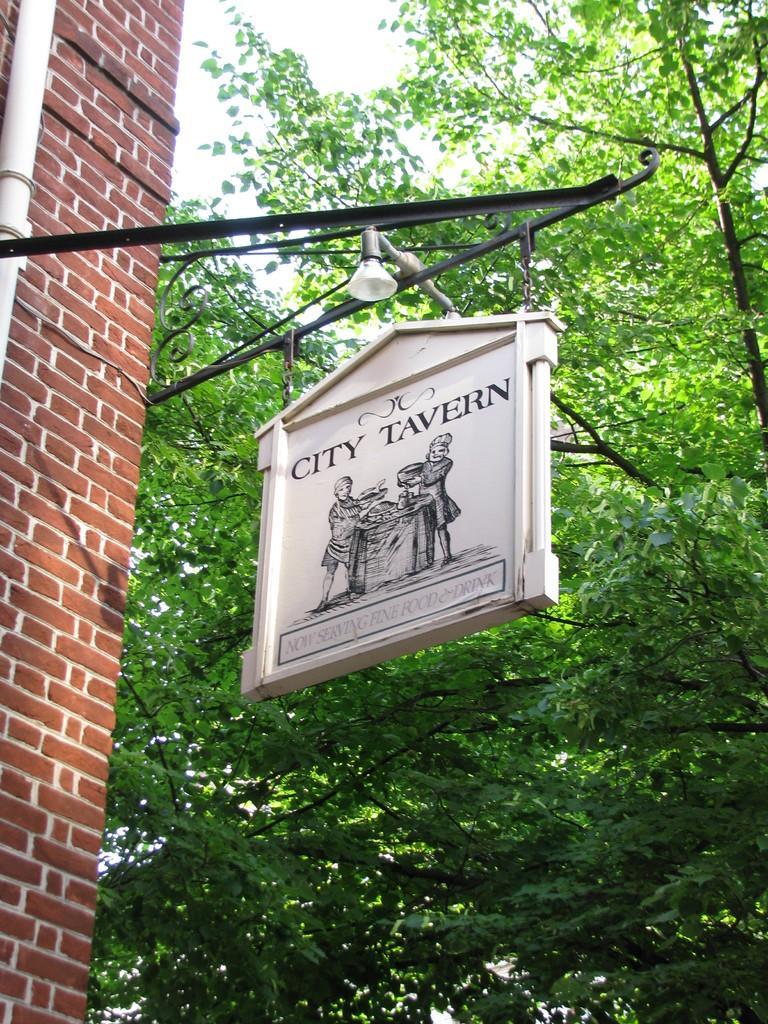In one or two sentences, can you explain what this image depicts? In this picture we can see a sign board hanging from an iron rod surrounded by trees and a red brick wall. 